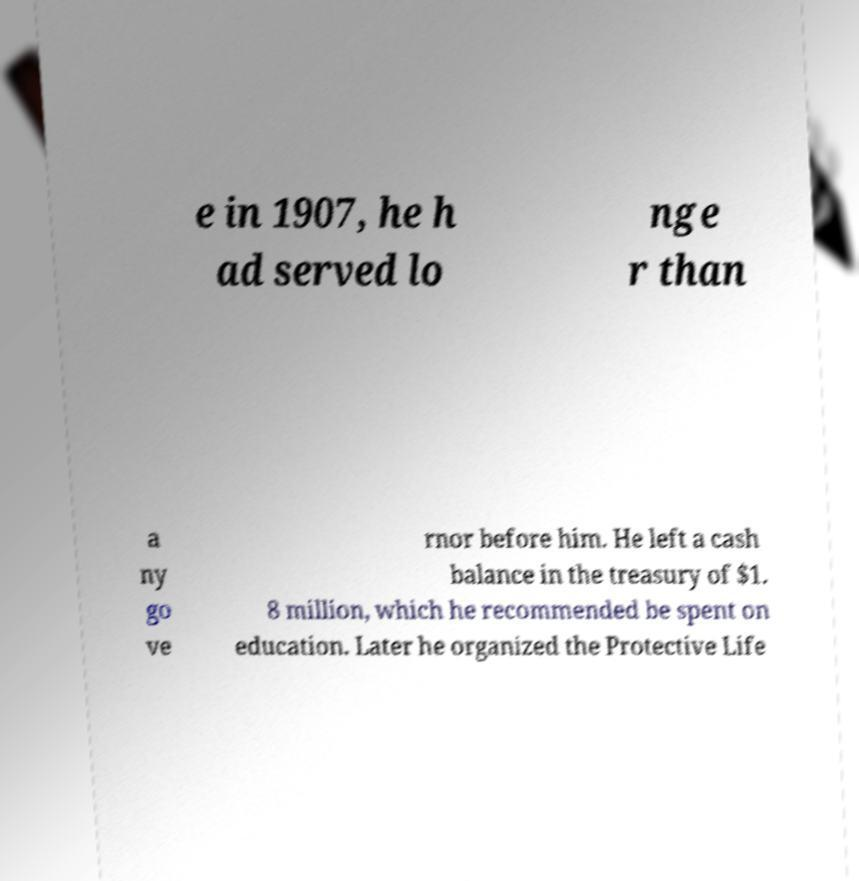Could you extract and type out the text from this image? e in 1907, he h ad served lo nge r than a ny go ve rnor before him. He left a cash balance in the treasury of $1. 8 million, which he recommended be spent on education. Later he organized the Protective Life 